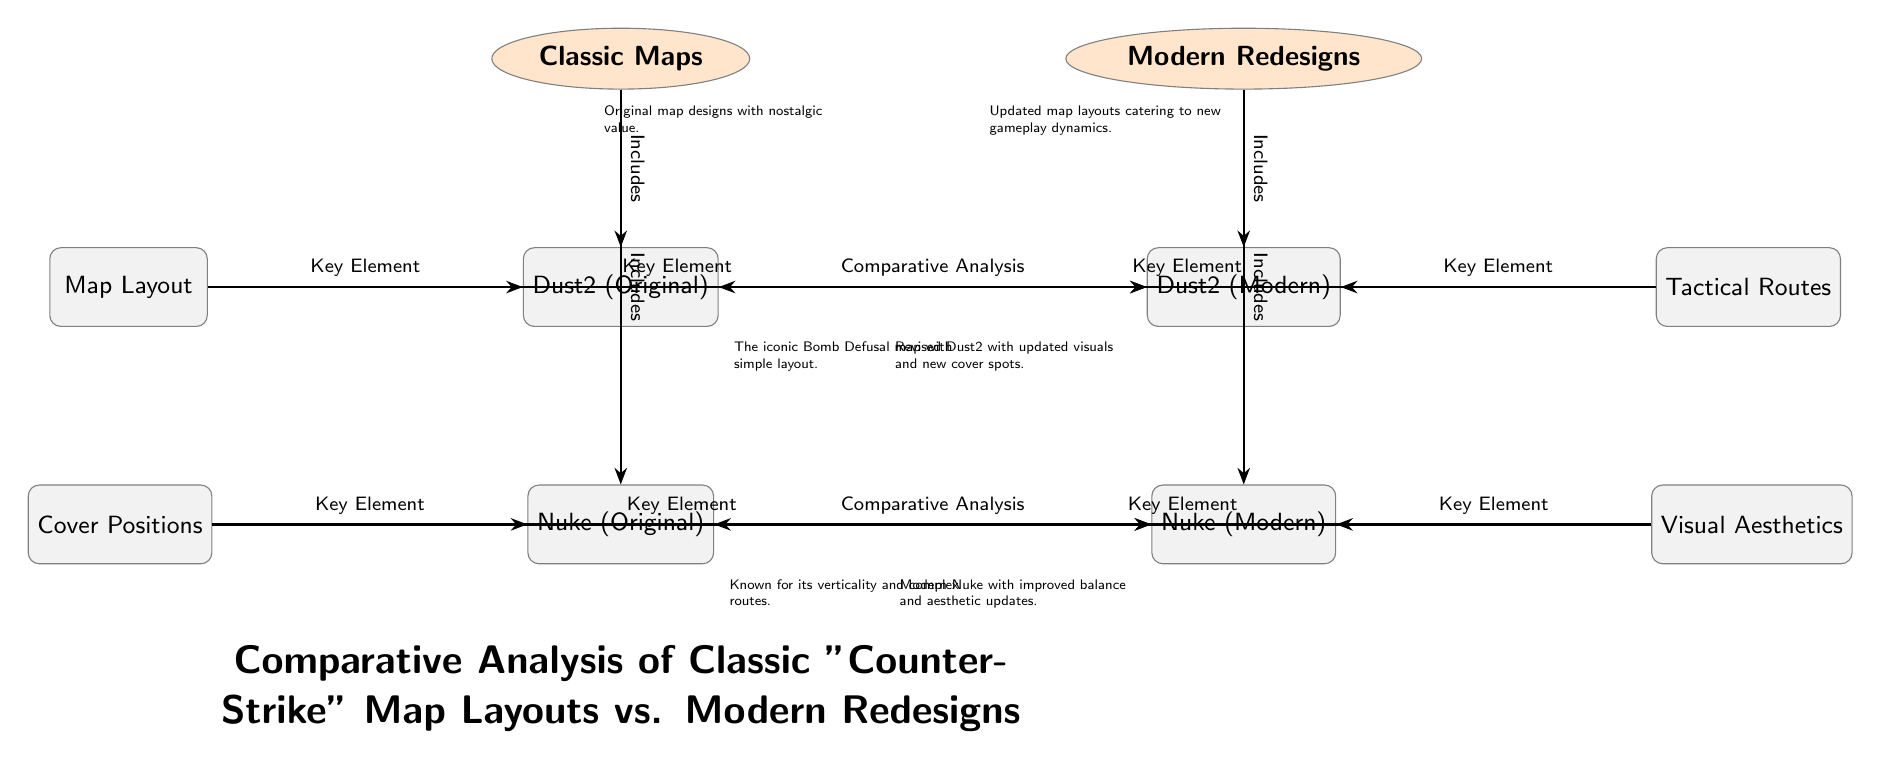What's included in the "Classic Maps" category? The diagram shows that the "Classic Maps" category includes both original versions of "Dust2" and "Nuke". This is evident from the lines connecting the category node to these two nodes, indicating that they are part of the classic maps.
Answer: Dust2, Nuke Which modern map redesign is paired with the original "Dust2"? The diagram shows a direct line labeled "Comparative Analysis" connecting "Dust2 (Original)" to "Dust2 (Modern)", indicating that "Dust2 (Modern)" is the modern redesign that corresponds to the original "Dust2".
Answer: Dust2 (Modern) What is a key element related to "Nuke (Original)" shown in the diagram? The diagram highlights "Cover Positions" as a key element related to "Nuke (Original)". This is indicated by the line connecting the "Cover Positions" node to the "Nuke (Original)" node with the label "Key Element".
Answer: Cover Positions How many nodes are part of the "Modern Redesigns" category? The diagram includes two nodes under the "Modern Redesigns" category, specifically "Dust2 (Modern)" and "Nuke (Modern)". Counting these nodes gives a total of two.
Answer: 2 What aspect is improved in the modern version of "Nuke"? The diagram indicates that "Nuke (Modern)" features improved balance and aesthetic updates as stated in the description under this node. This reflects the modern design considerations in comparison with the original.
Answer: Balance, aesthetics What are classic map designs said to possess? The diagram mentions that classic map designs possess "nostalgic value," which is reflected in the description connected to the "Classic Maps" category node. This highlights the emotional connection players have with these maps.
Answer: Nostalgic value What connects "Tactical Routes" to both versions of "Dust2"? The connection between "Tactical Routes" and the nodes for both "Dust2 (Original)" and "Dust2 (Modern)" is marked by the line labeled "Key Element", indicating that tactical routes are an important aspect of both versions.
Answer: Key Element What does the node "Visual Aesthetics" relate to in the context of the maps? "Visual Aesthetics" is related to "Nuke (Modern)" and "Nuke (Original)", showing that this aspect is being compared between the classic and modern design of "Nuke". This is established through the connection named "Key Element".
Answer: Nuke (Original), Nuke (Modern) How is the layout described for the original "Dust2"? The original "Dust2" is described as having "a simple layout," which is stated in the description placed near the node for "Dust2 (Original)", highlighting its straightforward design compared to modern complexities.
Answer: Simple layout 